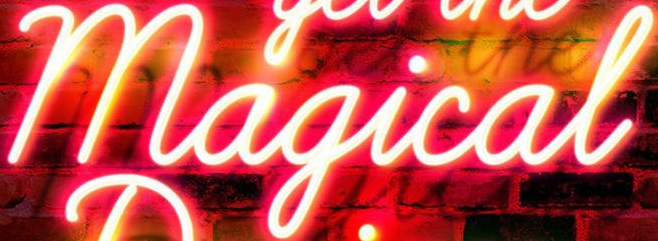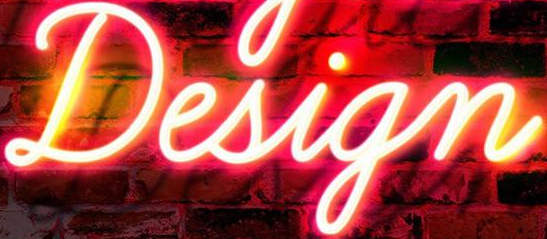Identify the words shown in these images in order, separated by a semicolon. Magical; Design 